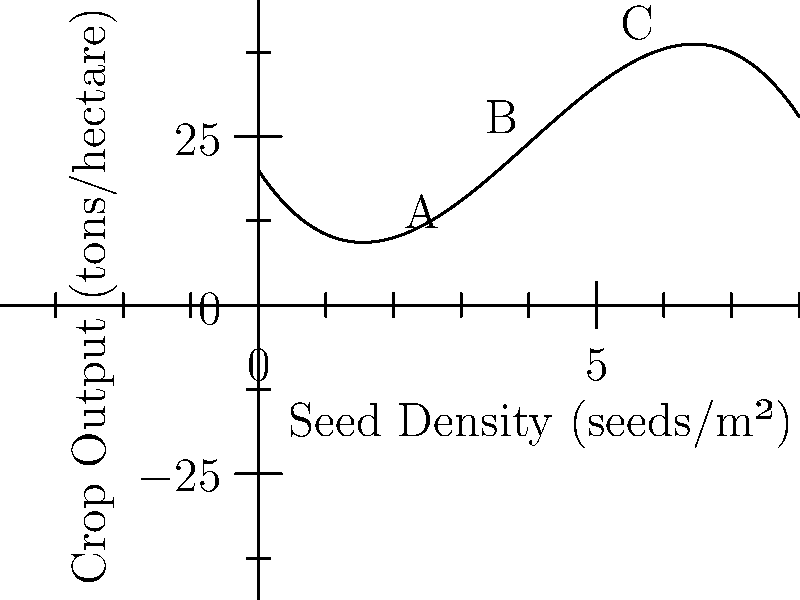The graph shows the relationship between seed density and crop output for a new hybrid corn variety. If the polynomial function describing this relationship is $f(x) = -0.5x^3 + 6x^2 - 15x + 20$, where $x$ is seed density in seeds/m² and $f(x)$ is crop output in tons/hectare, what is the optimal seed density to maximize crop output? How does this information impact the commercial potential of this hybrid variety? To find the optimal seed density that maximizes crop output, we need to follow these steps:

1) The maximum point of the function occurs where its derivative equals zero. Let's find the derivative:
   $f'(x) = -1.5x^2 + 12x - 15$

2) Set the derivative to zero and solve for x:
   $-1.5x^2 + 12x - 15 = 0$

3) This is a quadratic equation. We can solve it using the quadratic formula:
   $x = \frac{-b \pm \sqrt{b^2 - 4ac}}{2a}$

   Where $a = -1.5$, $b = 12$, and $c = -15$

4) Plugging in these values:
   $x = \frac{-12 \pm \sqrt{12^2 - 4(-1.5)(-15)}}{2(-1.5)}$
   $= \frac{-12 \pm \sqrt{144 - 90}}{-3}$
   $= \frac{-12 \pm \sqrt{54}}{-3}$
   $= \frac{-12 \pm 3\sqrt{6}}{-3}$

5) This gives us two solutions:
   $x_1 = 4 + \sqrt{6} \approx 6.45$
   $x_2 = 4 - \sqrt{6} \approx 1.55$

6) The larger value (6.45) corresponds to the maximum point on the graph.

The optimal seed density is approximately 6.45 seeds/m². This information impacts the commercial potential of the hybrid variety in several ways:

1) It provides farmers with a precise seeding rate to maximize their yield.
2) It allows for accurate cost calculations and profit projections.
3) It demonstrates the variety's high yield potential, which could command a premium price for seeds.
4) It shows that the variety performs well at relatively high seed densities, which could be attractive for intensive farming operations.
Answer: Optimal seed density: 6.45 seeds/m² 